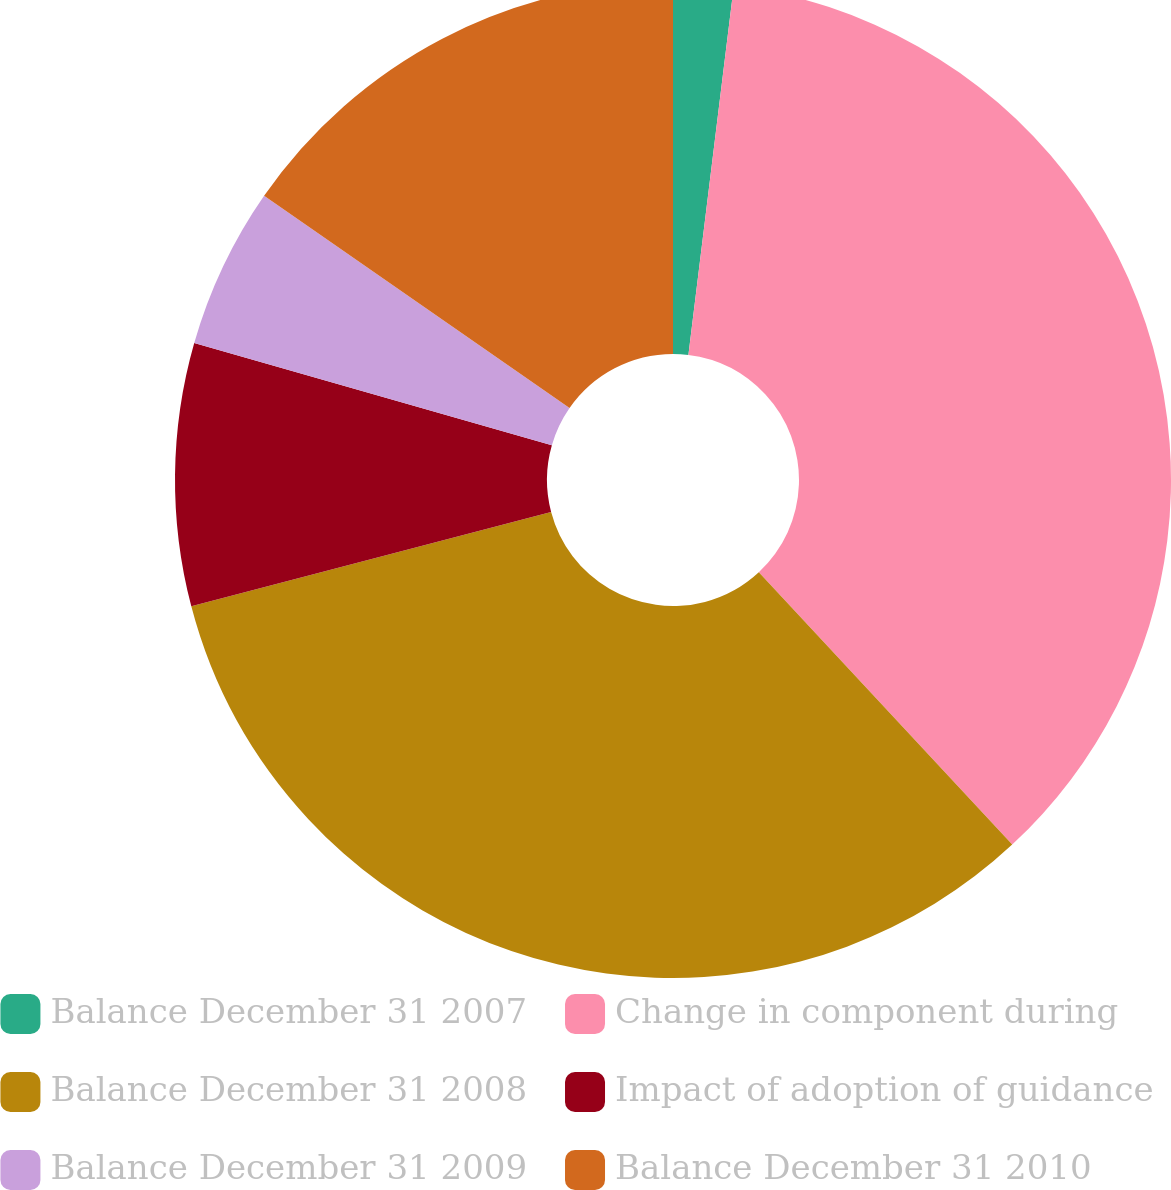Convert chart to OTSL. <chart><loc_0><loc_0><loc_500><loc_500><pie_chart><fcel>Balance December 31 2007<fcel>Change in component during<fcel>Balance December 31 2008<fcel>Impact of adoption of guidance<fcel>Balance December 31 2009<fcel>Balance December 31 2010<nl><fcel>1.95%<fcel>36.12%<fcel>32.84%<fcel>8.52%<fcel>5.23%<fcel>15.33%<nl></chart> 